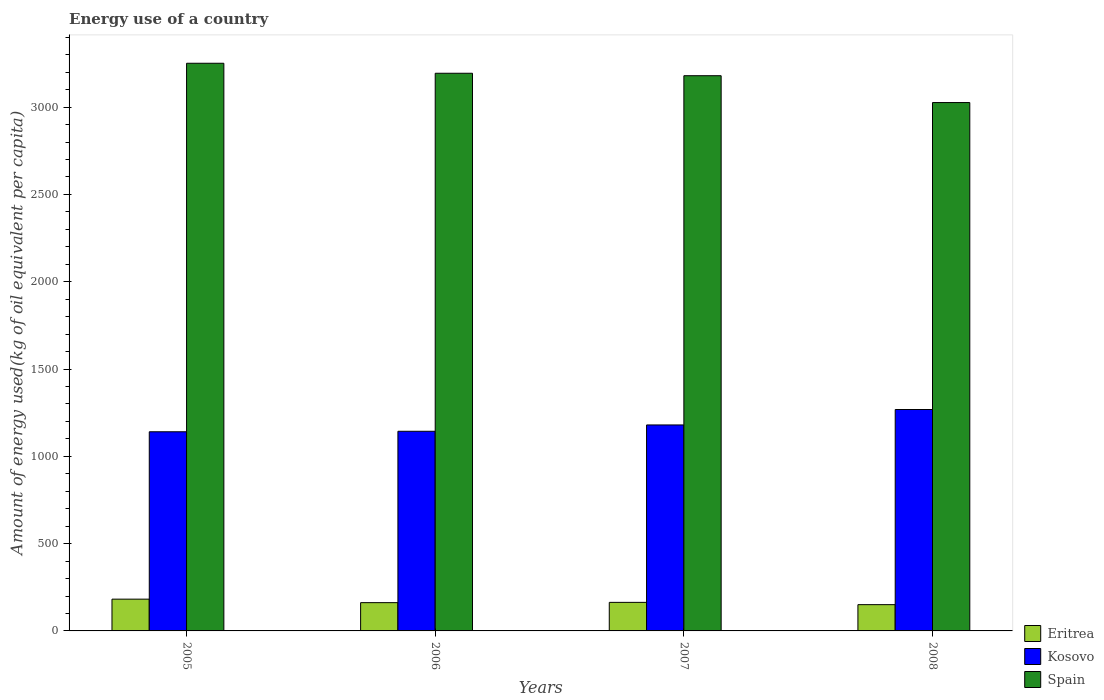How many groups of bars are there?
Your response must be concise. 4. Are the number of bars per tick equal to the number of legend labels?
Your answer should be very brief. Yes. Are the number of bars on each tick of the X-axis equal?
Give a very brief answer. Yes. How many bars are there on the 4th tick from the right?
Your response must be concise. 3. What is the label of the 4th group of bars from the left?
Offer a terse response. 2008. What is the amount of energy used in in Spain in 2005?
Keep it short and to the point. 3251.4. Across all years, what is the maximum amount of energy used in in Eritrea?
Your answer should be very brief. 182.02. Across all years, what is the minimum amount of energy used in in Eritrea?
Ensure brevity in your answer.  150.48. In which year was the amount of energy used in in Kosovo maximum?
Keep it short and to the point. 2008. What is the total amount of energy used in in Eritrea in the graph?
Provide a short and direct response. 657.96. What is the difference between the amount of energy used in in Spain in 2005 and that in 2007?
Provide a short and direct response. 71.36. What is the difference between the amount of energy used in in Eritrea in 2007 and the amount of energy used in in Spain in 2008?
Make the answer very short. -2862.79. What is the average amount of energy used in in Kosovo per year?
Keep it short and to the point. 1183.04. In the year 2005, what is the difference between the amount of energy used in in Kosovo and amount of energy used in in Spain?
Offer a very short reply. -2110.7. In how many years, is the amount of energy used in in Spain greater than 400 kg?
Provide a succinct answer. 4. What is the ratio of the amount of energy used in in Eritrea in 2007 to that in 2008?
Keep it short and to the point. 1.09. What is the difference between the highest and the second highest amount of energy used in in Eritrea?
Your answer should be very brief. 18.47. What is the difference between the highest and the lowest amount of energy used in in Eritrea?
Ensure brevity in your answer.  31.54. Is the sum of the amount of energy used in in Kosovo in 2006 and 2008 greater than the maximum amount of energy used in in Eritrea across all years?
Make the answer very short. Yes. What does the 2nd bar from the left in 2007 represents?
Provide a succinct answer. Kosovo. What does the 3rd bar from the right in 2008 represents?
Your response must be concise. Eritrea. Is it the case that in every year, the sum of the amount of energy used in in Kosovo and amount of energy used in in Eritrea is greater than the amount of energy used in in Spain?
Provide a succinct answer. No. How many years are there in the graph?
Your answer should be compact. 4. Does the graph contain grids?
Offer a very short reply. No. What is the title of the graph?
Ensure brevity in your answer.  Energy use of a country. Does "Benin" appear as one of the legend labels in the graph?
Keep it short and to the point. No. What is the label or title of the X-axis?
Your answer should be very brief. Years. What is the label or title of the Y-axis?
Make the answer very short. Amount of energy used(kg of oil equivalent per capita). What is the Amount of energy used(kg of oil equivalent per capita) of Eritrea in 2005?
Provide a succinct answer. 182.02. What is the Amount of energy used(kg of oil equivalent per capita) in Kosovo in 2005?
Offer a terse response. 1140.7. What is the Amount of energy used(kg of oil equivalent per capita) of Spain in 2005?
Make the answer very short. 3251.4. What is the Amount of energy used(kg of oil equivalent per capita) of Eritrea in 2006?
Offer a terse response. 161.91. What is the Amount of energy used(kg of oil equivalent per capita) of Kosovo in 2006?
Offer a very short reply. 1143.5. What is the Amount of energy used(kg of oil equivalent per capita) of Spain in 2006?
Offer a terse response. 3194.08. What is the Amount of energy used(kg of oil equivalent per capita) in Eritrea in 2007?
Ensure brevity in your answer.  163.55. What is the Amount of energy used(kg of oil equivalent per capita) in Kosovo in 2007?
Keep it short and to the point. 1179.76. What is the Amount of energy used(kg of oil equivalent per capita) of Spain in 2007?
Provide a succinct answer. 3180.03. What is the Amount of energy used(kg of oil equivalent per capita) in Eritrea in 2008?
Provide a short and direct response. 150.48. What is the Amount of energy used(kg of oil equivalent per capita) in Kosovo in 2008?
Offer a very short reply. 1268.2. What is the Amount of energy used(kg of oil equivalent per capita) in Spain in 2008?
Offer a terse response. 3026.34. Across all years, what is the maximum Amount of energy used(kg of oil equivalent per capita) of Eritrea?
Give a very brief answer. 182.02. Across all years, what is the maximum Amount of energy used(kg of oil equivalent per capita) in Kosovo?
Ensure brevity in your answer.  1268.2. Across all years, what is the maximum Amount of energy used(kg of oil equivalent per capita) of Spain?
Provide a succinct answer. 3251.4. Across all years, what is the minimum Amount of energy used(kg of oil equivalent per capita) in Eritrea?
Keep it short and to the point. 150.48. Across all years, what is the minimum Amount of energy used(kg of oil equivalent per capita) in Kosovo?
Offer a very short reply. 1140.7. Across all years, what is the minimum Amount of energy used(kg of oil equivalent per capita) of Spain?
Provide a short and direct response. 3026.34. What is the total Amount of energy used(kg of oil equivalent per capita) in Eritrea in the graph?
Provide a succinct answer. 657.96. What is the total Amount of energy used(kg of oil equivalent per capita) of Kosovo in the graph?
Give a very brief answer. 4732.16. What is the total Amount of energy used(kg of oil equivalent per capita) in Spain in the graph?
Provide a short and direct response. 1.27e+04. What is the difference between the Amount of energy used(kg of oil equivalent per capita) in Eritrea in 2005 and that in 2006?
Offer a very short reply. 20.1. What is the difference between the Amount of energy used(kg of oil equivalent per capita) of Kosovo in 2005 and that in 2006?
Ensure brevity in your answer.  -2.8. What is the difference between the Amount of energy used(kg of oil equivalent per capita) in Spain in 2005 and that in 2006?
Give a very brief answer. 57.32. What is the difference between the Amount of energy used(kg of oil equivalent per capita) in Eritrea in 2005 and that in 2007?
Provide a short and direct response. 18.47. What is the difference between the Amount of energy used(kg of oil equivalent per capita) in Kosovo in 2005 and that in 2007?
Keep it short and to the point. -39.06. What is the difference between the Amount of energy used(kg of oil equivalent per capita) of Spain in 2005 and that in 2007?
Offer a terse response. 71.36. What is the difference between the Amount of energy used(kg of oil equivalent per capita) of Eritrea in 2005 and that in 2008?
Ensure brevity in your answer.  31.54. What is the difference between the Amount of energy used(kg of oil equivalent per capita) in Kosovo in 2005 and that in 2008?
Provide a short and direct response. -127.5. What is the difference between the Amount of energy used(kg of oil equivalent per capita) in Spain in 2005 and that in 2008?
Your response must be concise. 225.06. What is the difference between the Amount of energy used(kg of oil equivalent per capita) of Eritrea in 2006 and that in 2007?
Provide a succinct answer. -1.63. What is the difference between the Amount of energy used(kg of oil equivalent per capita) in Kosovo in 2006 and that in 2007?
Ensure brevity in your answer.  -36.26. What is the difference between the Amount of energy used(kg of oil equivalent per capita) of Spain in 2006 and that in 2007?
Offer a terse response. 14.05. What is the difference between the Amount of energy used(kg of oil equivalent per capita) of Eritrea in 2006 and that in 2008?
Offer a very short reply. 11.44. What is the difference between the Amount of energy used(kg of oil equivalent per capita) in Kosovo in 2006 and that in 2008?
Keep it short and to the point. -124.7. What is the difference between the Amount of energy used(kg of oil equivalent per capita) in Spain in 2006 and that in 2008?
Ensure brevity in your answer.  167.74. What is the difference between the Amount of energy used(kg of oil equivalent per capita) in Eritrea in 2007 and that in 2008?
Your answer should be compact. 13.07. What is the difference between the Amount of energy used(kg of oil equivalent per capita) of Kosovo in 2007 and that in 2008?
Ensure brevity in your answer.  -88.44. What is the difference between the Amount of energy used(kg of oil equivalent per capita) of Spain in 2007 and that in 2008?
Your answer should be compact. 153.69. What is the difference between the Amount of energy used(kg of oil equivalent per capita) in Eritrea in 2005 and the Amount of energy used(kg of oil equivalent per capita) in Kosovo in 2006?
Your answer should be very brief. -961.48. What is the difference between the Amount of energy used(kg of oil equivalent per capita) of Eritrea in 2005 and the Amount of energy used(kg of oil equivalent per capita) of Spain in 2006?
Your response must be concise. -3012.06. What is the difference between the Amount of energy used(kg of oil equivalent per capita) in Kosovo in 2005 and the Amount of energy used(kg of oil equivalent per capita) in Spain in 2006?
Give a very brief answer. -2053.38. What is the difference between the Amount of energy used(kg of oil equivalent per capita) of Eritrea in 2005 and the Amount of energy used(kg of oil equivalent per capita) of Kosovo in 2007?
Offer a very short reply. -997.74. What is the difference between the Amount of energy used(kg of oil equivalent per capita) in Eritrea in 2005 and the Amount of energy used(kg of oil equivalent per capita) in Spain in 2007?
Your response must be concise. -2998.01. What is the difference between the Amount of energy used(kg of oil equivalent per capita) in Kosovo in 2005 and the Amount of energy used(kg of oil equivalent per capita) in Spain in 2007?
Provide a succinct answer. -2039.33. What is the difference between the Amount of energy used(kg of oil equivalent per capita) of Eritrea in 2005 and the Amount of energy used(kg of oil equivalent per capita) of Kosovo in 2008?
Offer a terse response. -1086.18. What is the difference between the Amount of energy used(kg of oil equivalent per capita) of Eritrea in 2005 and the Amount of energy used(kg of oil equivalent per capita) of Spain in 2008?
Your answer should be very brief. -2844.32. What is the difference between the Amount of energy used(kg of oil equivalent per capita) in Kosovo in 2005 and the Amount of energy used(kg of oil equivalent per capita) in Spain in 2008?
Keep it short and to the point. -1885.64. What is the difference between the Amount of energy used(kg of oil equivalent per capita) in Eritrea in 2006 and the Amount of energy used(kg of oil equivalent per capita) in Kosovo in 2007?
Your answer should be very brief. -1017.84. What is the difference between the Amount of energy used(kg of oil equivalent per capita) in Eritrea in 2006 and the Amount of energy used(kg of oil equivalent per capita) in Spain in 2007?
Offer a terse response. -3018.12. What is the difference between the Amount of energy used(kg of oil equivalent per capita) in Kosovo in 2006 and the Amount of energy used(kg of oil equivalent per capita) in Spain in 2007?
Offer a very short reply. -2036.53. What is the difference between the Amount of energy used(kg of oil equivalent per capita) in Eritrea in 2006 and the Amount of energy used(kg of oil equivalent per capita) in Kosovo in 2008?
Provide a succinct answer. -1106.29. What is the difference between the Amount of energy used(kg of oil equivalent per capita) in Eritrea in 2006 and the Amount of energy used(kg of oil equivalent per capita) in Spain in 2008?
Offer a very short reply. -2864.42. What is the difference between the Amount of energy used(kg of oil equivalent per capita) in Kosovo in 2006 and the Amount of energy used(kg of oil equivalent per capita) in Spain in 2008?
Provide a succinct answer. -1882.84. What is the difference between the Amount of energy used(kg of oil equivalent per capita) in Eritrea in 2007 and the Amount of energy used(kg of oil equivalent per capita) in Kosovo in 2008?
Make the answer very short. -1104.65. What is the difference between the Amount of energy used(kg of oil equivalent per capita) of Eritrea in 2007 and the Amount of energy used(kg of oil equivalent per capita) of Spain in 2008?
Make the answer very short. -2862.79. What is the difference between the Amount of energy used(kg of oil equivalent per capita) of Kosovo in 2007 and the Amount of energy used(kg of oil equivalent per capita) of Spain in 2008?
Make the answer very short. -1846.58. What is the average Amount of energy used(kg of oil equivalent per capita) in Eritrea per year?
Your answer should be compact. 164.49. What is the average Amount of energy used(kg of oil equivalent per capita) of Kosovo per year?
Offer a very short reply. 1183.04. What is the average Amount of energy used(kg of oil equivalent per capita) of Spain per year?
Your answer should be compact. 3162.96. In the year 2005, what is the difference between the Amount of energy used(kg of oil equivalent per capita) in Eritrea and Amount of energy used(kg of oil equivalent per capita) in Kosovo?
Offer a very short reply. -958.68. In the year 2005, what is the difference between the Amount of energy used(kg of oil equivalent per capita) of Eritrea and Amount of energy used(kg of oil equivalent per capita) of Spain?
Offer a very short reply. -3069.38. In the year 2005, what is the difference between the Amount of energy used(kg of oil equivalent per capita) in Kosovo and Amount of energy used(kg of oil equivalent per capita) in Spain?
Provide a short and direct response. -2110.7. In the year 2006, what is the difference between the Amount of energy used(kg of oil equivalent per capita) of Eritrea and Amount of energy used(kg of oil equivalent per capita) of Kosovo?
Your answer should be very brief. -981.59. In the year 2006, what is the difference between the Amount of energy used(kg of oil equivalent per capita) of Eritrea and Amount of energy used(kg of oil equivalent per capita) of Spain?
Provide a short and direct response. -3032.17. In the year 2006, what is the difference between the Amount of energy used(kg of oil equivalent per capita) of Kosovo and Amount of energy used(kg of oil equivalent per capita) of Spain?
Ensure brevity in your answer.  -2050.58. In the year 2007, what is the difference between the Amount of energy used(kg of oil equivalent per capita) in Eritrea and Amount of energy used(kg of oil equivalent per capita) in Kosovo?
Your response must be concise. -1016.21. In the year 2007, what is the difference between the Amount of energy used(kg of oil equivalent per capita) of Eritrea and Amount of energy used(kg of oil equivalent per capita) of Spain?
Give a very brief answer. -3016.49. In the year 2007, what is the difference between the Amount of energy used(kg of oil equivalent per capita) in Kosovo and Amount of energy used(kg of oil equivalent per capita) in Spain?
Your answer should be compact. -2000.28. In the year 2008, what is the difference between the Amount of energy used(kg of oil equivalent per capita) in Eritrea and Amount of energy used(kg of oil equivalent per capita) in Kosovo?
Your response must be concise. -1117.72. In the year 2008, what is the difference between the Amount of energy used(kg of oil equivalent per capita) in Eritrea and Amount of energy used(kg of oil equivalent per capita) in Spain?
Your response must be concise. -2875.86. In the year 2008, what is the difference between the Amount of energy used(kg of oil equivalent per capita) in Kosovo and Amount of energy used(kg of oil equivalent per capita) in Spain?
Provide a short and direct response. -1758.14. What is the ratio of the Amount of energy used(kg of oil equivalent per capita) of Eritrea in 2005 to that in 2006?
Give a very brief answer. 1.12. What is the ratio of the Amount of energy used(kg of oil equivalent per capita) of Spain in 2005 to that in 2006?
Offer a terse response. 1.02. What is the ratio of the Amount of energy used(kg of oil equivalent per capita) of Eritrea in 2005 to that in 2007?
Give a very brief answer. 1.11. What is the ratio of the Amount of energy used(kg of oil equivalent per capita) of Kosovo in 2005 to that in 2007?
Offer a terse response. 0.97. What is the ratio of the Amount of energy used(kg of oil equivalent per capita) in Spain in 2005 to that in 2007?
Give a very brief answer. 1.02. What is the ratio of the Amount of energy used(kg of oil equivalent per capita) of Eritrea in 2005 to that in 2008?
Offer a very short reply. 1.21. What is the ratio of the Amount of energy used(kg of oil equivalent per capita) of Kosovo in 2005 to that in 2008?
Offer a very short reply. 0.9. What is the ratio of the Amount of energy used(kg of oil equivalent per capita) in Spain in 2005 to that in 2008?
Provide a short and direct response. 1.07. What is the ratio of the Amount of energy used(kg of oil equivalent per capita) in Eritrea in 2006 to that in 2007?
Keep it short and to the point. 0.99. What is the ratio of the Amount of energy used(kg of oil equivalent per capita) of Kosovo in 2006 to that in 2007?
Give a very brief answer. 0.97. What is the ratio of the Amount of energy used(kg of oil equivalent per capita) in Spain in 2006 to that in 2007?
Your response must be concise. 1. What is the ratio of the Amount of energy used(kg of oil equivalent per capita) in Eritrea in 2006 to that in 2008?
Your response must be concise. 1.08. What is the ratio of the Amount of energy used(kg of oil equivalent per capita) in Kosovo in 2006 to that in 2008?
Ensure brevity in your answer.  0.9. What is the ratio of the Amount of energy used(kg of oil equivalent per capita) of Spain in 2006 to that in 2008?
Your answer should be very brief. 1.06. What is the ratio of the Amount of energy used(kg of oil equivalent per capita) of Eritrea in 2007 to that in 2008?
Offer a very short reply. 1.09. What is the ratio of the Amount of energy used(kg of oil equivalent per capita) in Kosovo in 2007 to that in 2008?
Provide a succinct answer. 0.93. What is the ratio of the Amount of energy used(kg of oil equivalent per capita) of Spain in 2007 to that in 2008?
Make the answer very short. 1.05. What is the difference between the highest and the second highest Amount of energy used(kg of oil equivalent per capita) of Eritrea?
Your response must be concise. 18.47. What is the difference between the highest and the second highest Amount of energy used(kg of oil equivalent per capita) of Kosovo?
Your response must be concise. 88.44. What is the difference between the highest and the second highest Amount of energy used(kg of oil equivalent per capita) of Spain?
Provide a succinct answer. 57.32. What is the difference between the highest and the lowest Amount of energy used(kg of oil equivalent per capita) of Eritrea?
Give a very brief answer. 31.54. What is the difference between the highest and the lowest Amount of energy used(kg of oil equivalent per capita) of Kosovo?
Provide a succinct answer. 127.5. What is the difference between the highest and the lowest Amount of energy used(kg of oil equivalent per capita) of Spain?
Keep it short and to the point. 225.06. 